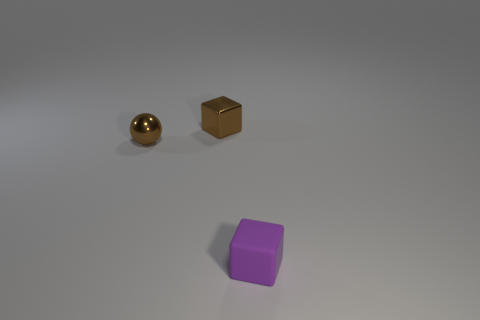Add 2 small brown metal things. How many objects exist? 5 Subtract all purple blocks. How many blocks are left? 1 Subtract all blocks. How many objects are left? 1 Add 1 small metallic blocks. How many small metallic blocks are left? 2 Add 2 tiny rubber objects. How many tiny rubber objects exist? 3 Subtract 0 red spheres. How many objects are left? 3 Subtract all cyan cubes. Subtract all green spheres. How many cubes are left? 2 Subtract all small shiny spheres. Subtract all rubber spheres. How many objects are left? 2 